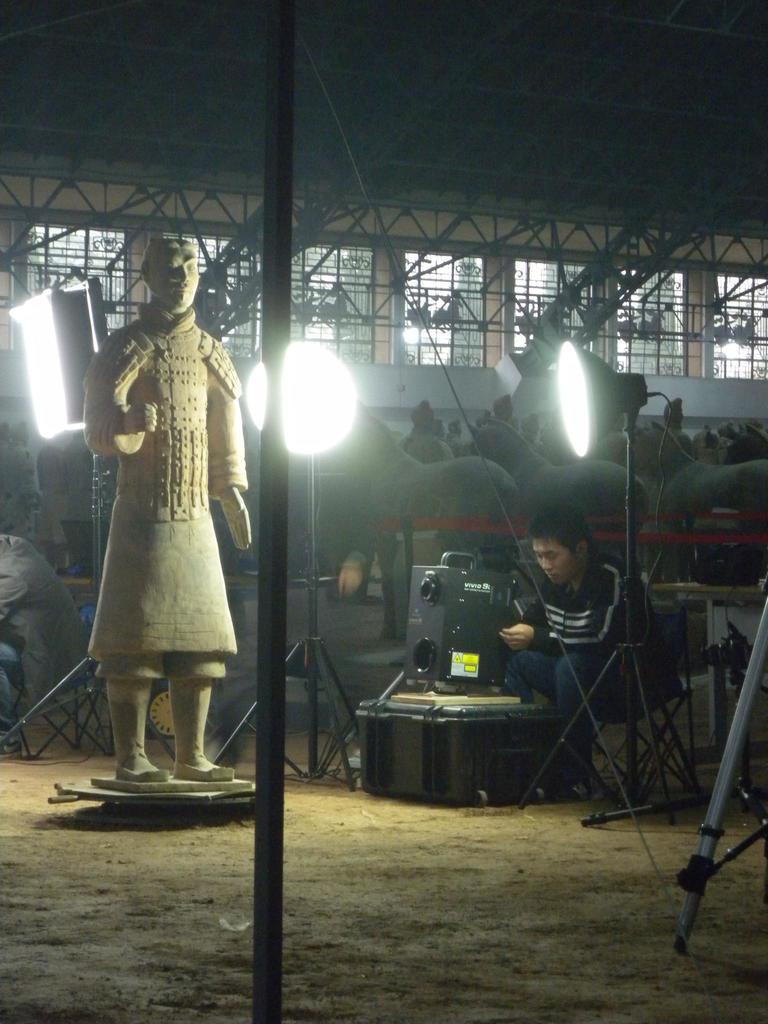In one or two sentences, can you explain what this image depicts? On the left side of this image there is a statue. On the right side there is a person sitting. Around him there are few machine tools and there are few lights. In the background there is a building. This is an image clicked in the dark. 